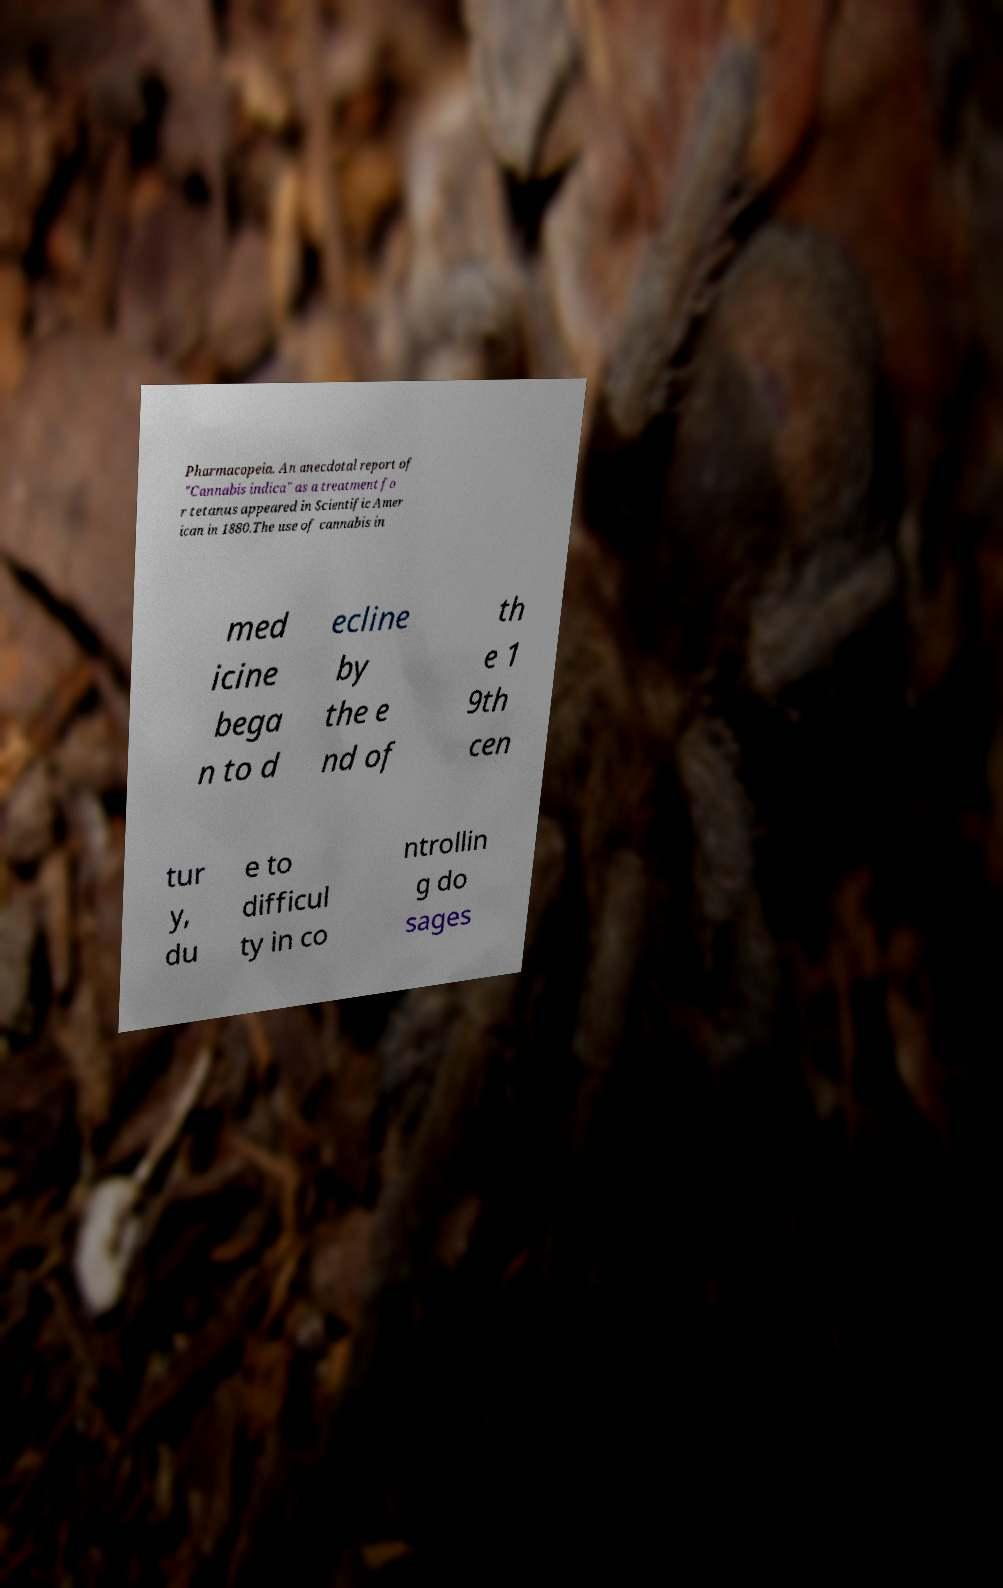Could you extract and type out the text from this image? Pharmacopeia. An anecdotal report of "Cannabis indica" as a treatment fo r tetanus appeared in Scientific Amer ican in 1880.The use of cannabis in med icine bega n to d ecline by the e nd of th e 1 9th cen tur y, du e to difficul ty in co ntrollin g do sages 